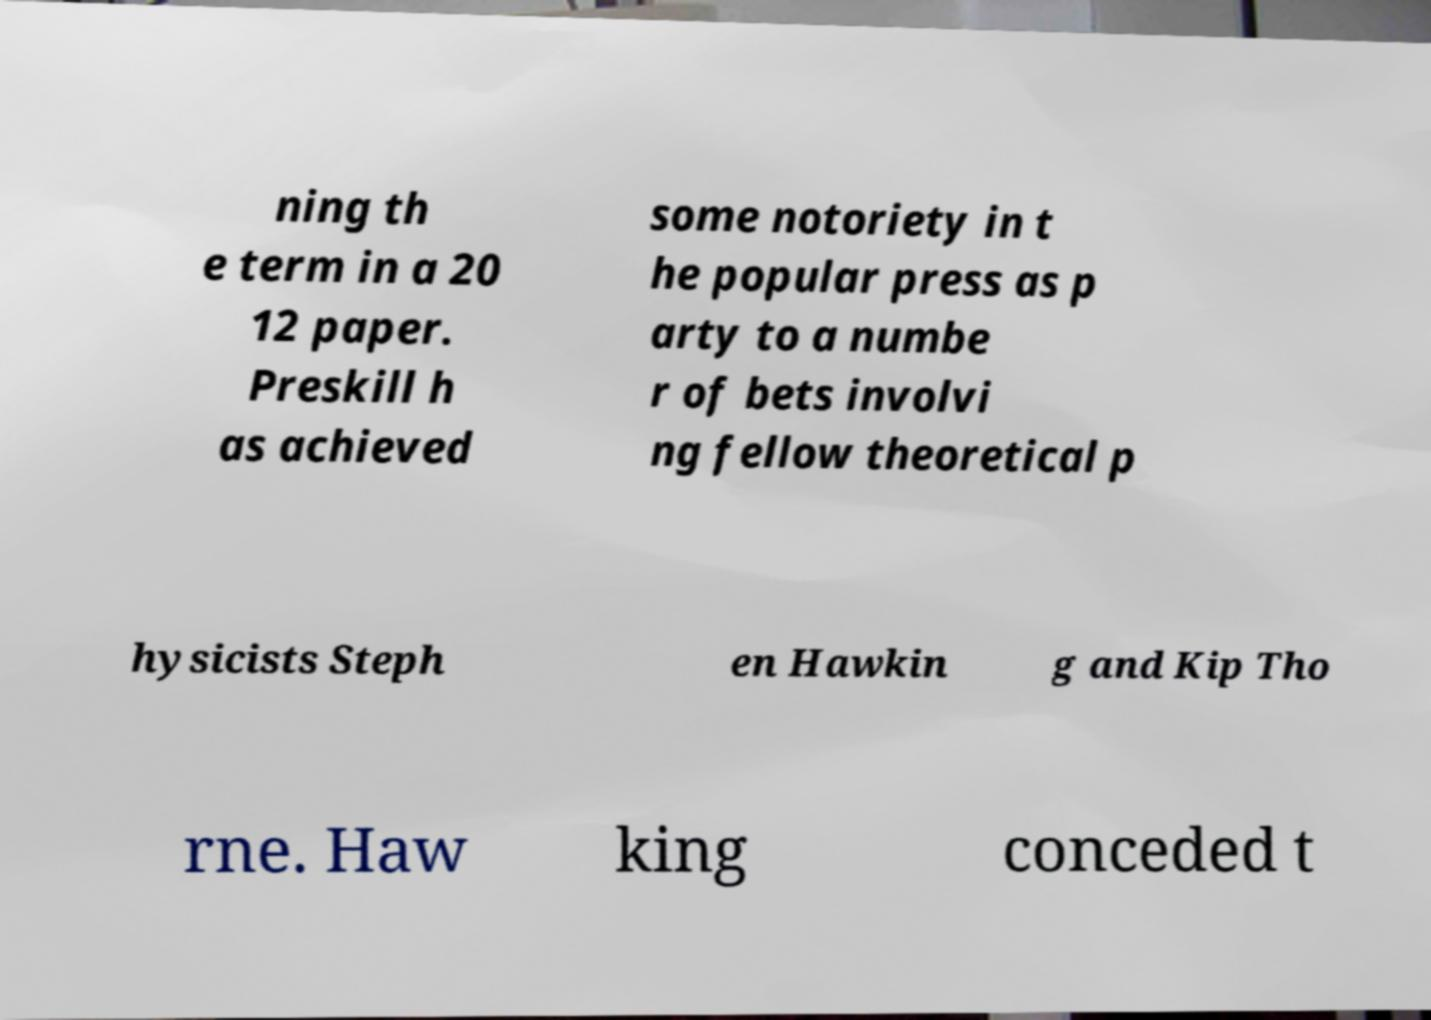What messages or text are displayed in this image? I need them in a readable, typed format. ning th e term in a 20 12 paper. Preskill h as achieved some notoriety in t he popular press as p arty to a numbe r of bets involvi ng fellow theoretical p hysicists Steph en Hawkin g and Kip Tho rne. Haw king conceded t 